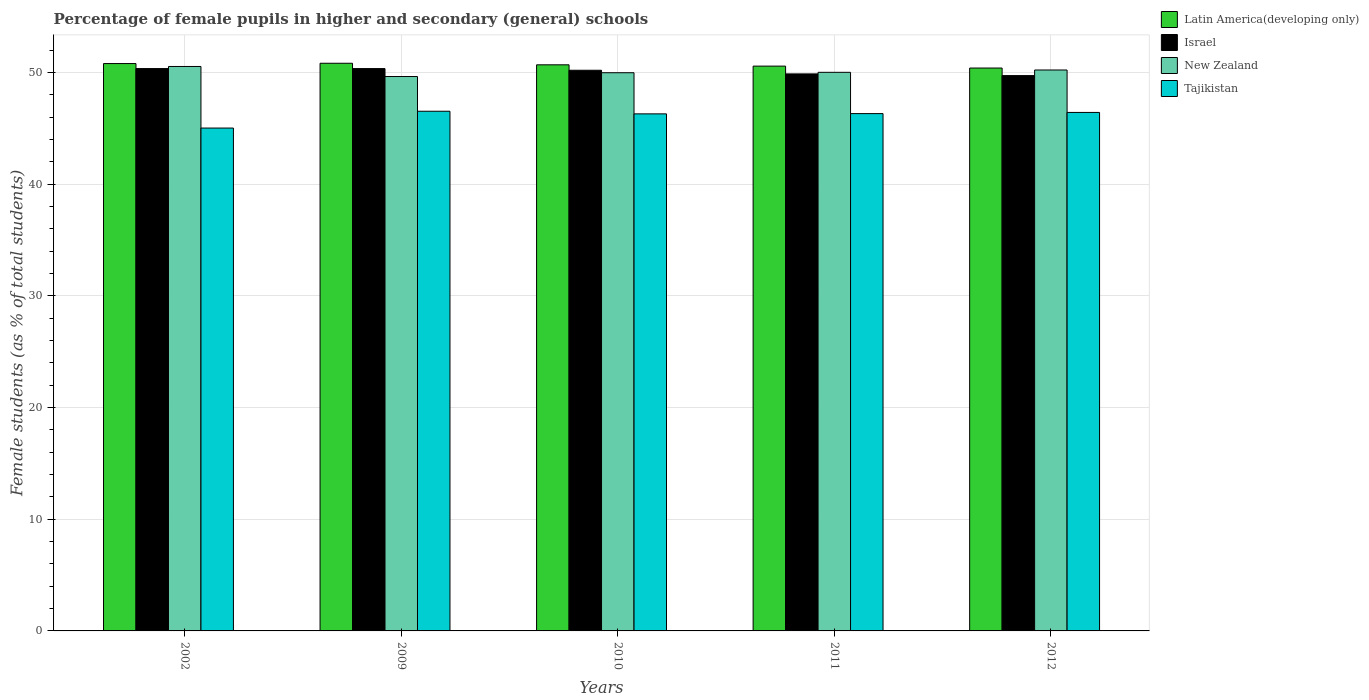How many different coloured bars are there?
Offer a very short reply. 4. How many groups of bars are there?
Give a very brief answer. 5. Are the number of bars per tick equal to the number of legend labels?
Your answer should be compact. Yes. Are the number of bars on each tick of the X-axis equal?
Offer a very short reply. Yes. What is the percentage of female pupils in higher and secondary schools in Tajikistan in 2010?
Offer a very short reply. 46.3. Across all years, what is the maximum percentage of female pupils in higher and secondary schools in New Zealand?
Provide a succinct answer. 50.54. Across all years, what is the minimum percentage of female pupils in higher and secondary schools in New Zealand?
Offer a terse response. 49.64. What is the total percentage of female pupils in higher and secondary schools in Latin America(developing only) in the graph?
Your response must be concise. 253.28. What is the difference between the percentage of female pupils in higher and secondary schools in Tajikistan in 2010 and that in 2012?
Give a very brief answer. -0.13. What is the difference between the percentage of female pupils in higher and secondary schools in New Zealand in 2011 and the percentage of female pupils in higher and secondary schools in Tajikistan in 2002?
Offer a terse response. 4.99. What is the average percentage of female pupils in higher and secondary schools in Israel per year?
Keep it short and to the point. 50.1. In the year 2009, what is the difference between the percentage of female pupils in higher and secondary schools in Tajikistan and percentage of female pupils in higher and secondary schools in Latin America(developing only)?
Give a very brief answer. -4.3. In how many years, is the percentage of female pupils in higher and secondary schools in Latin America(developing only) greater than 30 %?
Provide a short and direct response. 5. What is the ratio of the percentage of female pupils in higher and secondary schools in Tajikistan in 2010 to that in 2012?
Make the answer very short. 1. What is the difference between the highest and the second highest percentage of female pupils in higher and secondary schools in Latin America(developing only)?
Your answer should be very brief. 0.03. What is the difference between the highest and the lowest percentage of female pupils in higher and secondary schools in Latin America(developing only)?
Ensure brevity in your answer.  0.43. In how many years, is the percentage of female pupils in higher and secondary schools in New Zealand greater than the average percentage of female pupils in higher and secondary schools in New Zealand taken over all years?
Give a very brief answer. 2. Is it the case that in every year, the sum of the percentage of female pupils in higher and secondary schools in New Zealand and percentage of female pupils in higher and secondary schools in Latin America(developing only) is greater than the sum of percentage of female pupils in higher and secondary schools in Tajikistan and percentage of female pupils in higher and secondary schools in Israel?
Provide a short and direct response. No. What does the 2nd bar from the right in 2002 represents?
Keep it short and to the point. New Zealand. Is it the case that in every year, the sum of the percentage of female pupils in higher and secondary schools in New Zealand and percentage of female pupils in higher and secondary schools in Latin America(developing only) is greater than the percentage of female pupils in higher and secondary schools in Israel?
Your response must be concise. Yes. Are all the bars in the graph horizontal?
Make the answer very short. No. What is the difference between two consecutive major ticks on the Y-axis?
Your answer should be very brief. 10. How many legend labels are there?
Offer a very short reply. 4. How are the legend labels stacked?
Provide a succinct answer. Vertical. What is the title of the graph?
Give a very brief answer. Percentage of female pupils in higher and secondary (general) schools. What is the label or title of the X-axis?
Offer a terse response. Years. What is the label or title of the Y-axis?
Provide a short and direct response. Female students (as % of total students). What is the Female students (as % of total students) of Latin America(developing only) in 2002?
Provide a short and direct response. 50.8. What is the Female students (as % of total students) in Israel in 2002?
Provide a short and direct response. 50.35. What is the Female students (as % of total students) in New Zealand in 2002?
Your answer should be very brief. 50.54. What is the Female students (as % of total students) of Tajikistan in 2002?
Offer a very short reply. 45.03. What is the Female students (as % of total students) in Latin America(developing only) in 2009?
Your answer should be compact. 50.83. What is the Female students (as % of total students) of Israel in 2009?
Make the answer very short. 50.35. What is the Female students (as % of total students) of New Zealand in 2009?
Your answer should be very brief. 49.64. What is the Female students (as % of total students) in Tajikistan in 2009?
Offer a terse response. 46.53. What is the Female students (as % of total students) of Latin America(developing only) in 2010?
Your answer should be very brief. 50.69. What is the Female students (as % of total students) in Israel in 2010?
Ensure brevity in your answer.  50.2. What is the Female students (as % of total students) in New Zealand in 2010?
Ensure brevity in your answer.  49.98. What is the Female students (as % of total students) in Tajikistan in 2010?
Your answer should be compact. 46.3. What is the Female students (as % of total students) in Latin America(developing only) in 2011?
Ensure brevity in your answer.  50.57. What is the Female students (as % of total students) of Israel in 2011?
Offer a terse response. 49.87. What is the Female students (as % of total students) of New Zealand in 2011?
Offer a very short reply. 50.02. What is the Female students (as % of total students) of Tajikistan in 2011?
Offer a terse response. 46.32. What is the Female students (as % of total students) of Latin America(developing only) in 2012?
Provide a short and direct response. 50.4. What is the Female students (as % of total students) in Israel in 2012?
Your answer should be compact. 49.72. What is the Female students (as % of total students) in New Zealand in 2012?
Keep it short and to the point. 50.22. What is the Female students (as % of total students) in Tajikistan in 2012?
Provide a succinct answer. 46.42. Across all years, what is the maximum Female students (as % of total students) of Latin America(developing only)?
Your response must be concise. 50.83. Across all years, what is the maximum Female students (as % of total students) of Israel?
Keep it short and to the point. 50.35. Across all years, what is the maximum Female students (as % of total students) of New Zealand?
Ensure brevity in your answer.  50.54. Across all years, what is the maximum Female students (as % of total students) in Tajikistan?
Offer a terse response. 46.53. Across all years, what is the minimum Female students (as % of total students) in Latin America(developing only)?
Offer a very short reply. 50.4. Across all years, what is the minimum Female students (as % of total students) in Israel?
Offer a terse response. 49.72. Across all years, what is the minimum Female students (as % of total students) of New Zealand?
Keep it short and to the point. 49.64. Across all years, what is the minimum Female students (as % of total students) of Tajikistan?
Offer a very short reply. 45.03. What is the total Female students (as % of total students) in Latin America(developing only) in the graph?
Keep it short and to the point. 253.28. What is the total Female students (as % of total students) of Israel in the graph?
Ensure brevity in your answer.  250.5. What is the total Female students (as % of total students) in New Zealand in the graph?
Offer a very short reply. 250.4. What is the total Female students (as % of total students) of Tajikistan in the graph?
Give a very brief answer. 230.59. What is the difference between the Female students (as % of total students) of Latin America(developing only) in 2002 and that in 2009?
Your response must be concise. -0.03. What is the difference between the Female students (as % of total students) of Israel in 2002 and that in 2009?
Keep it short and to the point. 0. What is the difference between the Female students (as % of total students) of New Zealand in 2002 and that in 2009?
Offer a terse response. 0.9. What is the difference between the Female students (as % of total students) of Tajikistan in 2002 and that in 2009?
Offer a very short reply. -1.51. What is the difference between the Female students (as % of total students) of Latin America(developing only) in 2002 and that in 2010?
Your answer should be compact. 0.11. What is the difference between the Female students (as % of total students) in Israel in 2002 and that in 2010?
Your answer should be very brief. 0.15. What is the difference between the Female students (as % of total students) in New Zealand in 2002 and that in 2010?
Make the answer very short. 0.56. What is the difference between the Female students (as % of total students) of Tajikistan in 2002 and that in 2010?
Make the answer very short. -1.27. What is the difference between the Female students (as % of total students) of Latin America(developing only) in 2002 and that in 2011?
Your answer should be compact. 0.23. What is the difference between the Female students (as % of total students) of Israel in 2002 and that in 2011?
Your answer should be very brief. 0.48. What is the difference between the Female students (as % of total students) of New Zealand in 2002 and that in 2011?
Offer a very short reply. 0.52. What is the difference between the Female students (as % of total students) of Tajikistan in 2002 and that in 2011?
Offer a very short reply. -1.29. What is the difference between the Female students (as % of total students) in Latin America(developing only) in 2002 and that in 2012?
Keep it short and to the point. 0.4. What is the difference between the Female students (as % of total students) of Israel in 2002 and that in 2012?
Ensure brevity in your answer.  0.63. What is the difference between the Female students (as % of total students) in New Zealand in 2002 and that in 2012?
Keep it short and to the point. 0.32. What is the difference between the Female students (as % of total students) of Tajikistan in 2002 and that in 2012?
Make the answer very short. -1.4. What is the difference between the Female students (as % of total students) of Latin America(developing only) in 2009 and that in 2010?
Provide a succinct answer. 0.14. What is the difference between the Female students (as % of total students) of Israel in 2009 and that in 2010?
Make the answer very short. 0.15. What is the difference between the Female students (as % of total students) in New Zealand in 2009 and that in 2010?
Offer a terse response. -0.34. What is the difference between the Female students (as % of total students) in Tajikistan in 2009 and that in 2010?
Make the answer very short. 0.24. What is the difference between the Female students (as % of total students) in Latin America(developing only) in 2009 and that in 2011?
Your response must be concise. 0.26. What is the difference between the Female students (as % of total students) in Israel in 2009 and that in 2011?
Provide a short and direct response. 0.48. What is the difference between the Female students (as % of total students) of New Zealand in 2009 and that in 2011?
Your answer should be compact. -0.38. What is the difference between the Female students (as % of total students) of Tajikistan in 2009 and that in 2011?
Offer a terse response. 0.21. What is the difference between the Female students (as % of total students) of Latin America(developing only) in 2009 and that in 2012?
Provide a short and direct response. 0.43. What is the difference between the Female students (as % of total students) of Israel in 2009 and that in 2012?
Provide a short and direct response. 0.63. What is the difference between the Female students (as % of total students) of New Zealand in 2009 and that in 2012?
Keep it short and to the point. -0.58. What is the difference between the Female students (as % of total students) in Tajikistan in 2009 and that in 2012?
Provide a short and direct response. 0.11. What is the difference between the Female students (as % of total students) in Latin America(developing only) in 2010 and that in 2011?
Provide a succinct answer. 0.12. What is the difference between the Female students (as % of total students) of Israel in 2010 and that in 2011?
Your response must be concise. 0.33. What is the difference between the Female students (as % of total students) in New Zealand in 2010 and that in 2011?
Give a very brief answer. -0.04. What is the difference between the Female students (as % of total students) of Tajikistan in 2010 and that in 2011?
Offer a very short reply. -0.02. What is the difference between the Female students (as % of total students) in Latin America(developing only) in 2010 and that in 2012?
Give a very brief answer. 0.29. What is the difference between the Female students (as % of total students) of Israel in 2010 and that in 2012?
Provide a succinct answer. 0.48. What is the difference between the Female students (as % of total students) in New Zealand in 2010 and that in 2012?
Ensure brevity in your answer.  -0.24. What is the difference between the Female students (as % of total students) in Tajikistan in 2010 and that in 2012?
Ensure brevity in your answer.  -0.13. What is the difference between the Female students (as % of total students) in Latin America(developing only) in 2011 and that in 2012?
Provide a short and direct response. 0.17. What is the difference between the Female students (as % of total students) in Israel in 2011 and that in 2012?
Provide a succinct answer. 0.15. What is the difference between the Female students (as % of total students) in New Zealand in 2011 and that in 2012?
Make the answer very short. -0.21. What is the difference between the Female students (as % of total students) in Tajikistan in 2011 and that in 2012?
Ensure brevity in your answer.  -0.11. What is the difference between the Female students (as % of total students) of Latin America(developing only) in 2002 and the Female students (as % of total students) of Israel in 2009?
Ensure brevity in your answer.  0.45. What is the difference between the Female students (as % of total students) of Latin America(developing only) in 2002 and the Female students (as % of total students) of New Zealand in 2009?
Provide a short and direct response. 1.16. What is the difference between the Female students (as % of total students) in Latin America(developing only) in 2002 and the Female students (as % of total students) in Tajikistan in 2009?
Provide a succinct answer. 4.27. What is the difference between the Female students (as % of total students) in Israel in 2002 and the Female students (as % of total students) in New Zealand in 2009?
Give a very brief answer. 0.71. What is the difference between the Female students (as % of total students) of Israel in 2002 and the Female students (as % of total students) of Tajikistan in 2009?
Give a very brief answer. 3.82. What is the difference between the Female students (as % of total students) in New Zealand in 2002 and the Female students (as % of total students) in Tajikistan in 2009?
Your answer should be compact. 4.01. What is the difference between the Female students (as % of total students) of Latin America(developing only) in 2002 and the Female students (as % of total students) of Israel in 2010?
Your answer should be very brief. 0.6. What is the difference between the Female students (as % of total students) in Latin America(developing only) in 2002 and the Female students (as % of total students) in New Zealand in 2010?
Provide a short and direct response. 0.82. What is the difference between the Female students (as % of total students) of Latin America(developing only) in 2002 and the Female students (as % of total students) of Tajikistan in 2010?
Your answer should be very brief. 4.5. What is the difference between the Female students (as % of total students) of Israel in 2002 and the Female students (as % of total students) of New Zealand in 2010?
Your response must be concise. 0.37. What is the difference between the Female students (as % of total students) of Israel in 2002 and the Female students (as % of total students) of Tajikistan in 2010?
Keep it short and to the point. 4.06. What is the difference between the Female students (as % of total students) of New Zealand in 2002 and the Female students (as % of total students) of Tajikistan in 2010?
Keep it short and to the point. 4.24. What is the difference between the Female students (as % of total students) in Latin America(developing only) in 2002 and the Female students (as % of total students) in Israel in 2011?
Your answer should be very brief. 0.93. What is the difference between the Female students (as % of total students) in Latin America(developing only) in 2002 and the Female students (as % of total students) in New Zealand in 2011?
Provide a succinct answer. 0.78. What is the difference between the Female students (as % of total students) of Latin America(developing only) in 2002 and the Female students (as % of total students) of Tajikistan in 2011?
Make the answer very short. 4.48. What is the difference between the Female students (as % of total students) in Israel in 2002 and the Female students (as % of total students) in New Zealand in 2011?
Ensure brevity in your answer.  0.34. What is the difference between the Female students (as % of total students) in Israel in 2002 and the Female students (as % of total students) in Tajikistan in 2011?
Give a very brief answer. 4.03. What is the difference between the Female students (as % of total students) in New Zealand in 2002 and the Female students (as % of total students) in Tajikistan in 2011?
Ensure brevity in your answer.  4.22. What is the difference between the Female students (as % of total students) in Latin America(developing only) in 2002 and the Female students (as % of total students) in Israel in 2012?
Provide a succinct answer. 1.08. What is the difference between the Female students (as % of total students) of Latin America(developing only) in 2002 and the Female students (as % of total students) of New Zealand in 2012?
Give a very brief answer. 0.58. What is the difference between the Female students (as % of total students) in Latin America(developing only) in 2002 and the Female students (as % of total students) in Tajikistan in 2012?
Give a very brief answer. 4.38. What is the difference between the Female students (as % of total students) in Israel in 2002 and the Female students (as % of total students) in New Zealand in 2012?
Your answer should be very brief. 0.13. What is the difference between the Female students (as % of total students) of Israel in 2002 and the Female students (as % of total students) of Tajikistan in 2012?
Offer a terse response. 3.93. What is the difference between the Female students (as % of total students) in New Zealand in 2002 and the Female students (as % of total students) in Tajikistan in 2012?
Provide a short and direct response. 4.11. What is the difference between the Female students (as % of total students) in Latin America(developing only) in 2009 and the Female students (as % of total students) in Israel in 2010?
Your response must be concise. 0.63. What is the difference between the Female students (as % of total students) in Latin America(developing only) in 2009 and the Female students (as % of total students) in New Zealand in 2010?
Offer a terse response. 0.85. What is the difference between the Female students (as % of total students) in Latin America(developing only) in 2009 and the Female students (as % of total students) in Tajikistan in 2010?
Offer a very short reply. 4.53. What is the difference between the Female students (as % of total students) of Israel in 2009 and the Female students (as % of total students) of New Zealand in 2010?
Offer a terse response. 0.37. What is the difference between the Female students (as % of total students) of Israel in 2009 and the Female students (as % of total students) of Tajikistan in 2010?
Give a very brief answer. 4.06. What is the difference between the Female students (as % of total students) in New Zealand in 2009 and the Female students (as % of total students) in Tajikistan in 2010?
Your answer should be very brief. 3.34. What is the difference between the Female students (as % of total students) of Latin America(developing only) in 2009 and the Female students (as % of total students) of Israel in 2011?
Offer a very short reply. 0.95. What is the difference between the Female students (as % of total students) of Latin America(developing only) in 2009 and the Female students (as % of total students) of New Zealand in 2011?
Provide a short and direct response. 0.81. What is the difference between the Female students (as % of total students) of Latin America(developing only) in 2009 and the Female students (as % of total students) of Tajikistan in 2011?
Provide a short and direct response. 4.51. What is the difference between the Female students (as % of total students) in Israel in 2009 and the Female students (as % of total students) in New Zealand in 2011?
Keep it short and to the point. 0.34. What is the difference between the Female students (as % of total students) in Israel in 2009 and the Female students (as % of total students) in Tajikistan in 2011?
Provide a short and direct response. 4.03. What is the difference between the Female students (as % of total students) of New Zealand in 2009 and the Female students (as % of total students) of Tajikistan in 2011?
Your response must be concise. 3.32. What is the difference between the Female students (as % of total students) in Latin America(developing only) in 2009 and the Female students (as % of total students) in Israel in 2012?
Offer a very short reply. 1.11. What is the difference between the Female students (as % of total students) of Latin America(developing only) in 2009 and the Female students (as % of total students) of New Zealand in 2012?
Provide a succinct answer. 0.6. What is the difference between the Female students (as % of total students) of Latin America(developing only) in 2009 and the Female students (as % of total students) of Tajikistan in 2012?
Give a very brief answer. 4.4. What is the difference between the Female students (as % of total students) of Israel in 2009 and the Female students (as % of total students) of New Zealand in 2012?
Provide a short and direct response. 0.13. What is the difference between the Female students (as % of total students) in Israel in 2009 and the Female students (as % of total students) in Tajikistan in 2012?
Your answer should be compact. 3.93. What is the difference between the Female students (as % of total students) in New Zealand in 2009 and the Female students (as % of total students) in Tajikistan in 2012?
Give a very brief answer. 3.21. What is the difference between the Female students (as % of total students) in Latin America(developing only) in 2010 and the Female students (as % of total students) in Israel in 2011?
Your answer should be very brief. 0.81. What is the difference between the Female students (as % of total students) in Latin America(developing only) in 2010 and the Female students (as % of total students) in New Zealand in 2011?
Give a very brief answer. 0.67. What is the difference between the Female students (as % of total students) in Latin America(developing only) in 2010 and the Female students (as % of total students) in Tajikistan in 2011?
Keep it short and to the point. 4.37. What is the difference between the Female students (as % of total students) of Israel in 2010 and the Female students (as % of total students) of New Zealand in 2011?
Give a very brief answer. 0.18. What is the difference between the Female students (as % of total students) of Israel in 2010 and the Female students (as % of total students) of Tajikistan in 2011?
Make the answer very short. 3.88. What is the difference between the Female students (as % of total students) of New Zealand in 2010 and the Female students (as % of total students) of Tajikistan in 2011?
Offer a very short reply. 3.66. What is the difference between the Female students (as % of total students) of Latin America(developing only) in 2010 and the Female students (as % of total students) of Israel in 2012?
Provide a succinct answer. 0.97. What is the difference between the Female students (as % of total students) in Latin America(developing only) in 2010 and the Female students (as % of total students) in New Zealand in 2012?
Provide a succinct answer. 0.46. What is the difference between the Female students (as % of total students) in Latin America(developing only) in 2010 and the Female students (as % of total students) in Tajikistan in 2012?
Offer a very short reply. 4.26. What is the difference between the Female students (as % of total students) in Israel in 2010 and the Female students (as % of total students) in New Zealand in 2012?
Provide a succinct answer. -0.02. What is the difference between the Female students (as % of total students) in Israel in 2010 and the Female students (as % of total students) in Tajikistan in 2012?
Your answer should be very brief. 3.78. What is the difference between the Female students (as % of total students) of New Zealand in 2010 and the Female students (as % of total students) of Tajikistan in 2012?
Provide a succinct answer. 3.55. What is the difference between the Female students (as % of total students) in Latin America(developing only) in 2011 and the Female students (as % of total students) in Israel in 2012?
Offer a terse response. 0.85. What is the difference between the Female students (as % of total students) of Latin America(developing only) in 2011 and the Female students (as % of total students) of New Zealand in 2012?
Your answer should be very brief. 0.35. What is the difference between the Female students (as % of total students) of Latin America(developing only) in 2011 and the Female students (as % of total students) of Tajikistan in 2012?
Provide a short and direct response. 4.15. What is the difference between the Female students (as % of total students) in Israel in 2011 and the Female students (as % of total students) in New Zealand in 2012?
Your answer should be compact. -0.35. What is the difference between the Female students (as % of total students) of Israel in 2011 and the Female students (as % of total students) of Tajikistan in 2012?
Ensure brevity in your answer.  3.45. What is the difference between the Female students (as % of total students) of New Zealand in 2011 and the Female students (as % of total students) of Tajikistan in 2012?
Ensure brevity in your answer.  3.59. What is the average Female students (as % of total students) in Latin America(developing only) per year?
Offer a very short reply. 50.66. What is the average Female students (as % of total students) of Israel per year?
Offer a terse response. 50.1. What is the average Female students (as % of total students) in New Zealand per year?
Offer a very short reply. 50.08. What is the average Female students (as % of total students) of Tajikistan per year?
Ensure brevity in your answer.  46.12. In the year 2002, what is the difference between the Female students (as % of total students) in Latin America(developing only) and Female students (as % of total students) in Israel?
Offer a very short reply. 0.45. In the year 2002, what is the difference between the Female students (as % of total students) of Latin America(developing only) and Female students (as % of total students) of New Zealand?
Offer a terse response. 0.26. In the year 2002, what is the difference between the Female students (as % of total students) of Latin America(developing only) and Female students (as % of total students) of Tajikistan?
Your answer should be compact. 5.77. In the year 2002, what is the difference between the Female students (as % of total students) in Israel and Female students (as % of total students) in New Zealand?
Offer a very short reply. -0.19. In the year 2002, what is the difference between the Female students (as % of total students) of Israel and Female students (as % of total students) of Tajikistan?
Offer a terse response. 5.33. In the year 2002, what is the difference between the Female students (as % of total students) in New Zealand and Female students (as % of total students) in Tajikistan?
Provide a succinct answer. 5.51. In the year 2009, what is the difference between the Female students (as % of total students) of Latin America(developing only) and Female students (as % of total students) of Israel?
Your answer should be very brief. 0.48. In the year 2009, what is the difference between the Female students (as % of total students) of Latin America(developing only) and Female students (as % of total students) of New Zealand?
Provide a short and direct response. 1.19. In the year 2009, what is the difference between the Female students (as % of total students) of Latin America(developing only) and Female students (as % of total students) of Tajikistan?
Provide a succinct answer. 4.3. In the year 2009, what is the difference between the Female students (as % of total students) of Israel and Female students (as % of total students) of New Zealand?
Keep it short and to the point. 0.71. In the year 2009, what is the difference between the Female students (as % of total students) in Israel and Female students (as % of total students) in Tajikistan?
Your answer should be very brief. 3.82. In the year 2009, what is the difference between the Female students (as % of total students) of New Zealand and Female students (as % of total students) of Tajikistan?
Provide a succinct answer. 3.11. In the year 2010, what is the difference between the Female students (as % of total students) in Latin America(developing only) and Female students (as % of total students) in Israel?
Keep it short and to the point. 0.49. In the year 2010, what is the difference between the Female students (as % of total students) in Latin America(developing only) and Female students (as % of total students) in New Zealand?
Make the answer very short. 0.71. In the year 2010, what is the difference between the Female students (as % of total students) of Latin America(developing only) and Female students (as % of total students) of Tajikistan?
Your answer should be very brief. 4.39. In the year 2010, what is the difference between the Female students (as % of total students) of Israel and Female students (as % of total students) of New Zealand?
Your answer should be compact. 0.22. In the year 2010, what is the difference between the Female students (as % of total students) of Israel and Female students (as % of total students) of Tajikistan?
Ensure brevity in your answer.  3.9. In the year 2010, what is the difference between the Female students (as % of total students) of New Zealand and Female students (as % of total students) of Tajikistan?
Ensure brevity in your answer.  3.68. In the year 2011, what is the difference between the Female students (as % of total students) of Latin America(developing only) and Female students (as % of total students) of Israel?
Provide a short and direct response. 0.7. In the year 2011, what is the difference between the Female students (as % of total students) in Latin America(developing only) and Female students (as % of total students) in New Zealand?
Give a very brief answer. 0.56. In the year 2011, what is the difference between the Female students (as % of total students) of Latin America(developing only) and Female students (as % of total students) of Tajikistan?
Provide a short and direct response. 4.25. In the year 2011, what is the difference between the Female students (as % of total students) of Israel and Female students (as % of total students) of New Zealand?
Give a very brief answer. -0.14. In the year 2011, what is the difference between the Female students (as % of total students) of Israel and Female students (as % of total students) of Tajikistan?
Provide a succinct answer. 3.55. In the year 2011, what is the difference between the Female students (as % of total students) in New Zealand and Female students (as % of total students) in Tajikistan?
Provide a succinct answer. 3.7. In the year 2012, what is the difference between the Female students (as % of total students) in Latin America(developing only) and Female students (as % of total students) in Israel?
Make the answer very short. 0.68. In the year 2012, what is the difference between the Female students (as % of total students) of Latin America(developing only) and Female students (as % of total students) of New Zealand?
Provide a succinct answer. 0.17. In the year 2012, what is the difference between the Female students (as % of total students) in Latin America(developing only) and Female students (as % of total students) in Tajikistan?
Your answer should be compact. 3.97. In the year 2012, what is the difference between the Female students (as % of total students) of Israel and Female students (as % of total students) of New Zealand?
Your answer should be very brief. -0.5. In the year 2012, what is the difference between the Female students (as % of total students) in Israel and Female students (as % of total students) in Tajikistan?
Provide a succinct answer. 3.3. In the year 2012, what is the difference between the Female students (as % of total students) of New Zealand and Female students (as % of total students) of Tajikistan?
Ensure brevity in your answer.  3.8. What is the ratio of the Female students (as % of total students) of New Zealand in 2002 to that in 2009?
Ensure brevity in your answer.  1.02. What is the ratio of the Female students (as % of total students) of Tajikistan in 2002 to that in 2009?
Provide a short and direct response. 0.97. What is the ratio of the Female students (as % of total students) of Latin America(developing only) in 2002 to that in 2010?
Give a very brief answer. 1. What is the ratio of the Female students (as % of total students) of New Zealand in 2002 to that in 2010?
Your answer should be very brief. 1.01. What is the ratio of the Female students (as % of total students) of Tajikistan in 2002 to that in 2010?
Ensure brevity in your answer.  0.97. What is the ratio of the Female students (as % of total students) of Israel in 2002 to that in 2011?
Your answer should be very brief. 1.01. What is the ratio of the Female students (as % of total students) of New Zealand in 2002 to that in 2011?
Offer a terse response. 1.01. What is the ratio of the Female students (as % of total students) in Tajikistan in 2002 to that in 2011?
Ensure brevity in your answer.  0.97. What is the ratio of the Female students (as % of total students) in Israel in 2002 to that in 2012?
Offer a terse response. 1.01. What is the ratio of the Female students (as % of total students) of New Zealand in 2002 to that in 2012?
Provide a succinct answer. 1.01. What is the ratio of the Female students (as % of total students) in Tajikistan in 2002 to that in 2012?
Keep it short and to the point. 0.97. What is the ratio of the Female students (as % of total students) in Israel in 2009 to that in 2010?
Offer a terse response. 1. What is the ratio of the Female students (as % of total students) of Tajikistan in 2009 to that in 2010?
Your response must be concise. 1.01. What is the ratio of the Female students (as % of total students) in Latin America(developing only) in 2009 to that in 2011?
Offer a very short reply. 1.01. What is the ratio of the Female students (as % of total students) of Israel in 2009 to that in 2011?
Offer a very short reply. 1.01. What is the ratio of the Female students (as % of total students) in Tajikistan in 2009 to that in 2011?
Offer a terse response. 1. What is the ratio of the Female students (as % of total students) in Latin America(developing only) in 2009 to that in 2012?
Give a very brief answer. 1.01. What is the ratio of the Female students (as % of total students) of Israel in 2009 to that in 2012?
Your response must be concise. 1.01. What is the ratio of the Female students (as % of total students) of New Zealand in 2009 to that in 2012?
Make the answer very short. 0.99. What is the ratio of the Female students (as % of total students) of Latin America(developing only) in 2010 to that in 2011?
Make the answer very short. 1. What is the ratio of the Female students (as % of total students) in Israel in 2010 to that in 2011?
Give a very brief answer. 1.01. What is the ratio of the Female students (as % of total students) of Israel in 2010 to that in 2012?
Your answer should be compact. 1.01. What is the ratio of the Female students (as % of total students) of Tajikistan in 2010 to that in 2012?
Your answer should be very brief. 1. What is the ratio of the Female students (as % of total students) in New Zealand in 2011 to that in 2012?
Provide a succinct answer. 1. What is the ratio of the Female students (as % of total students) in Tajikistan in 2011 to that in 2012?
Offer a very short reply. 1. What is the difference between the highest and the second highest Female students (as % of total students) of Latin America(developing only)?
Keep it short and to the point. 0.03. What is the difference between the highest and the second highest Female students (as % of total students) of New Zealand?
Make the answer very short. 0.32. What is the difference between the highest and the second highest Female students (as % of total students) of Tajikistan?
Ensure brevity in your answer.  0.11. What is the difference between the highest and the lowest Female students (as % of total students) of Latin America(developing only)?
Your answer should be very brief. 0.43. What is the difference between the highest and the lowest Female students (as % of total students) of Israel?
Make the answer very short. 0.63. What is the difference between the highest and the lowest Female students (as % of total students) of New Zealand?
Give a very brief answer. 0.9. What is the difference between the highest and the lowest Female students (as % of total students) of Tajikistan?
Keep it short and to the point. 1.51. 